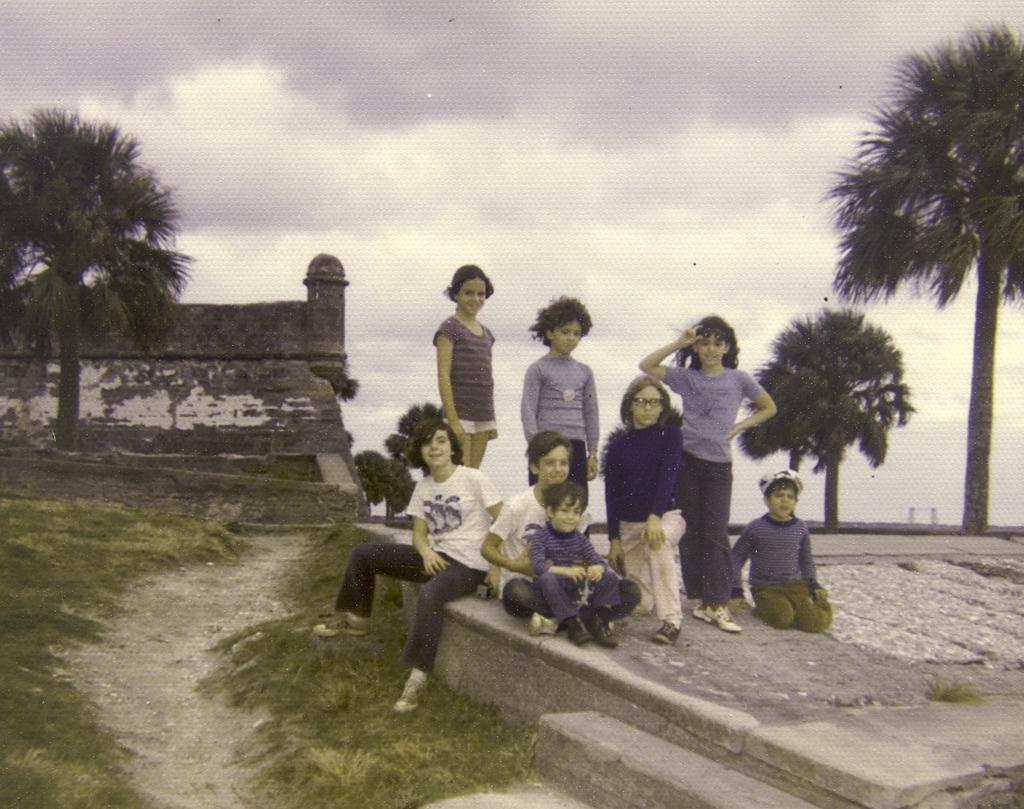Could you give a brief overview of what you see in this image? In this picture we can see group of people, few are sitting and few are standing, behind them we can see few trees, a building and clouds. 